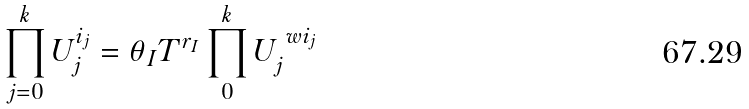Convert formula to latex. <formula><loc_0><loc_0><loc_500><loc_500>\prod _ { j = 0 } ^ { k } U _ { j } ^ { i _ { j } } = \theta _ { I } T ^ { r _ { I } } \prod _ { 0 } ^ { k } U _ { j } ^ { \ w i _ { j } }</formula> 